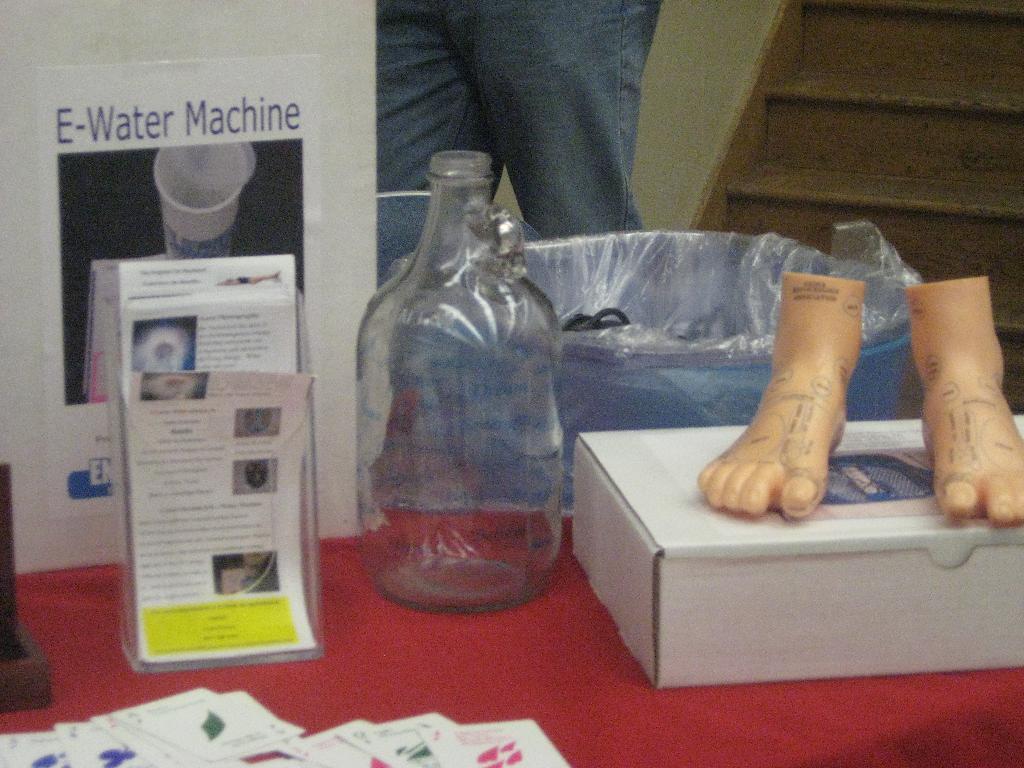How would you summarize this image in a sentence or two? In this image I can see a bottle, a container, a box and a paper. I can also see a person. 